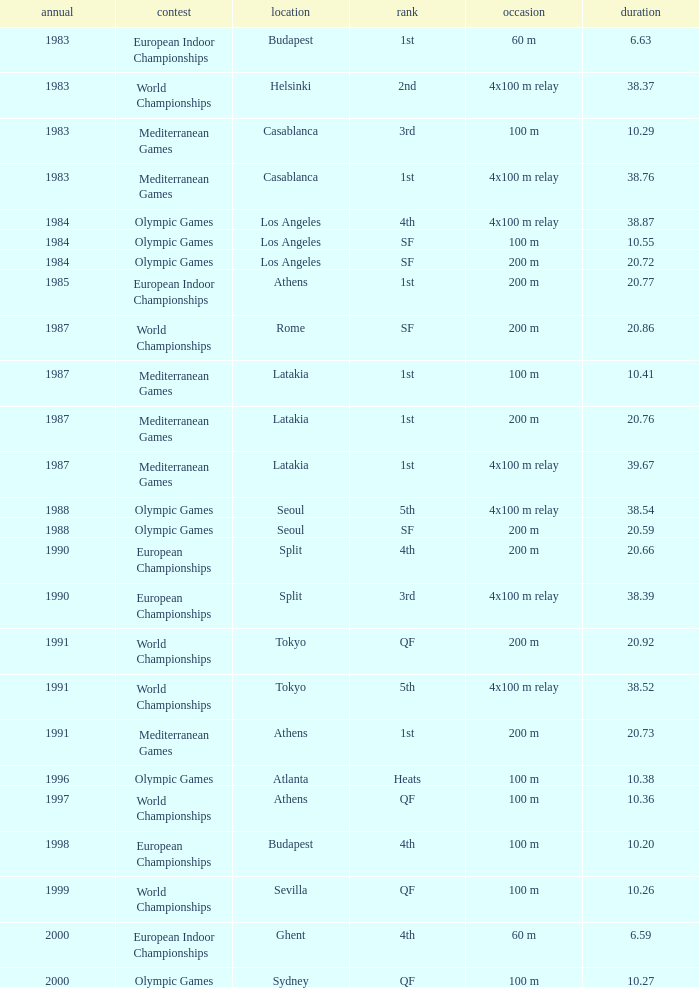What Venue has a Year smaller than 1991, Time larger than 10.29, Competition of mediterranean games, and Event of 4x100 m relay? Casablanca, Latakia. 